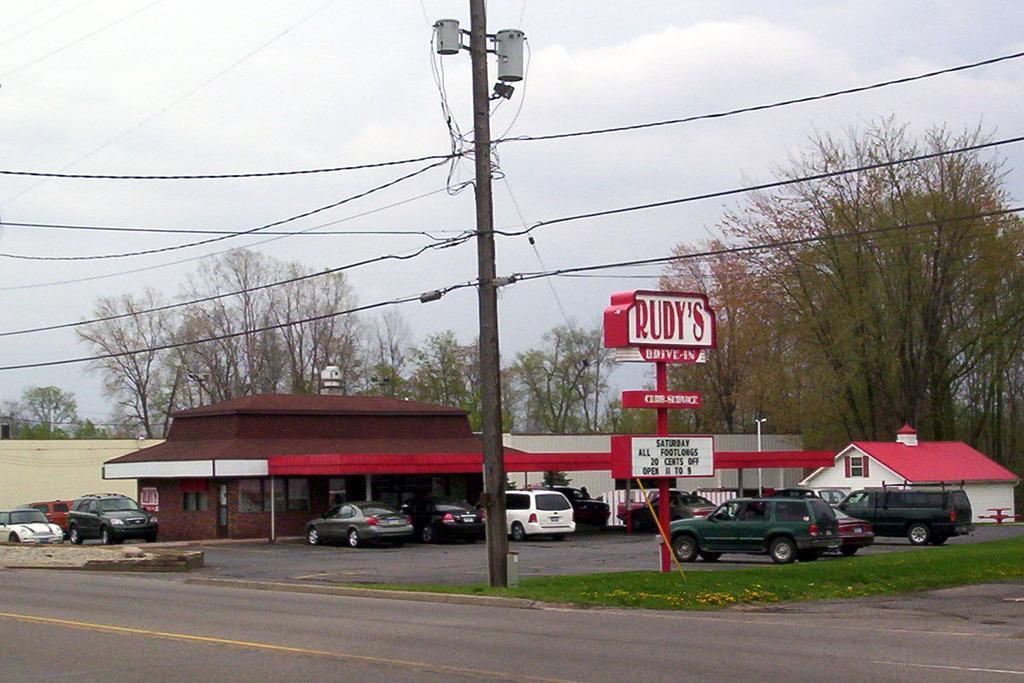Could you give a brief overview of what you see in this image? As we can see in the image there are trees, current pole, cars, grass, house and sky. 